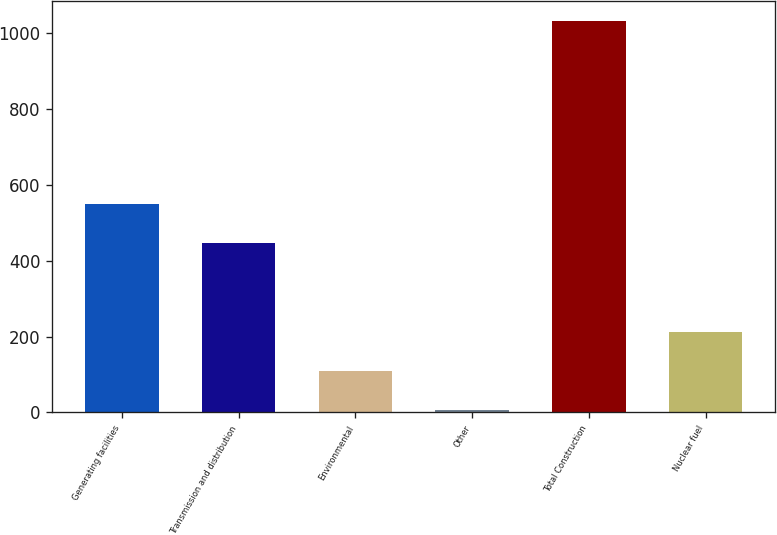<chart> <loc_0><loc_0><loc_500><loc_500><bar_chart><fcel>Generating facilities<fcel>Transmission and distribution<fcel>Environmental<fcel>Other<fcel>Total Construction<fcel>Nuclear fuel<nl><fcel>550.8<fcel>448<fcel>108.8<fcel>6<fcel>1034<fcel>211.6<nl></chart> 